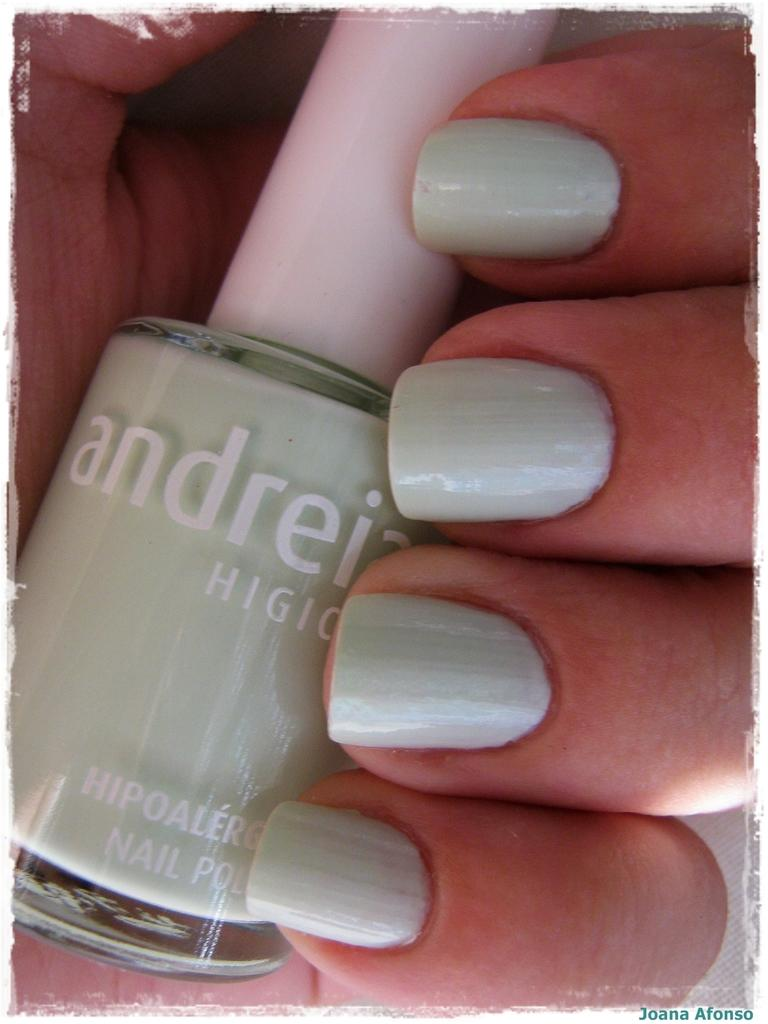<image>
Describe the image concisely. light green nail pollish with the brand andreia and a girl hand holiding it 